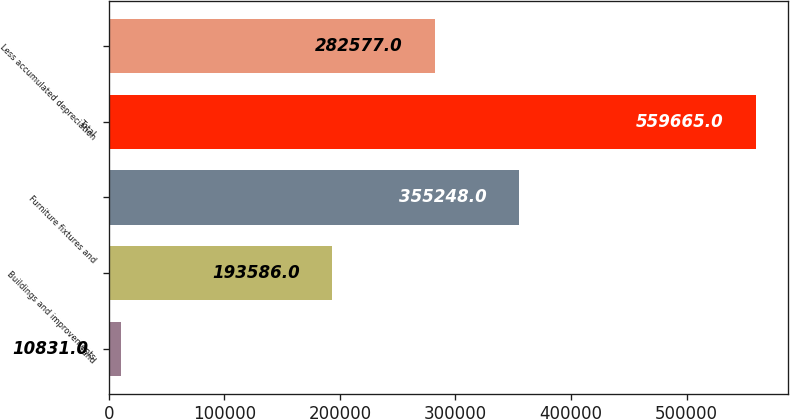Convert chart. <chart><loc_0><loc_0><loc_500><loc_500><bar_chart><fcel>Land<fcel>Buildings and improvements<fcel>Furniture fixtures and<fcel>Total<fcel>Less accumulated depreciation<nl><fcel>10831<fcel>193586<fcel>355248<fcel>559665<fcel>282577<nl></chart> 